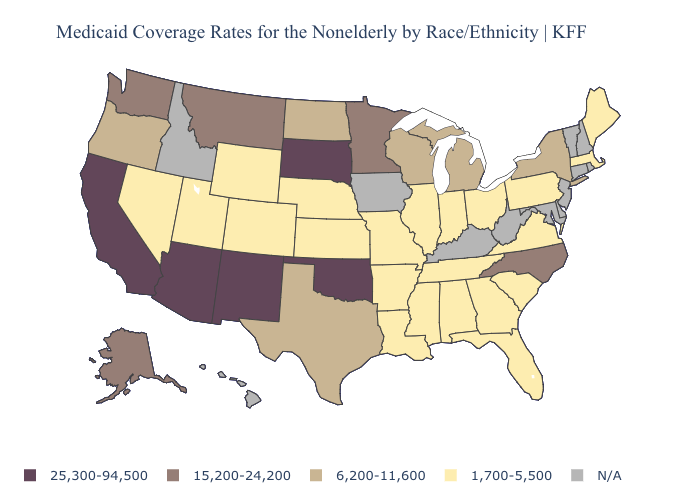What is the highest value in states that border Arizona?
Write a very short answer. 25,300-94,500. Among the states that border Kansas , which have the lowest value?
Concise answer only. Colorado, Missouri, Nebraska. How many symbols are there in the legend?
Answer briefly. 5. What is the value of Massachusetts?
Answer briefly. 1,700-5,500. What is the highest value in states that border New Hampshire?
Give a very brief answer. 1,700-5,500. Name the states that have a value in the range 15,200-24,200?
Give a very brief answer. Alaska, Minnesota, Montana, North Carolina, Washington. Name the states that have a value in the range N/A?
Quick response, please. Connecticut, Delaware, Hawaii, Idaho, Iowa, Kentucky, Maryland, New Hampshire, New Jersey, Rhode Island, Vermont, West Virginia. Name the states that have a value in the range N/A?
Be succinct. Connecticut, Delaware, Hawaii, Idaho, Iowa, Kentucky, Maryland, New Hampshire, New Jersey, Rhode Island, Vermont, West Virginia. What is the value of Nevada?
Answer briefly. 1,700-5,500. What is the value of New York?
Give a very brief answer. 6,200-11,600. Name the states that have a value in the range N/A?
Short answer required. Connecticut, Delaware, Hawaii, Idaho, Iowa, Kentucky, Maryland, New Hampshire, New Jersey, Rhode Island, Vermont, West Virginia. What is the value of California?
Short answer required. 25,300-94,500. Name the states that have a value in the range 15,200-24,200?
Short answer required. Alaska, Minnesota, Montana, North Carolina, Washington. 